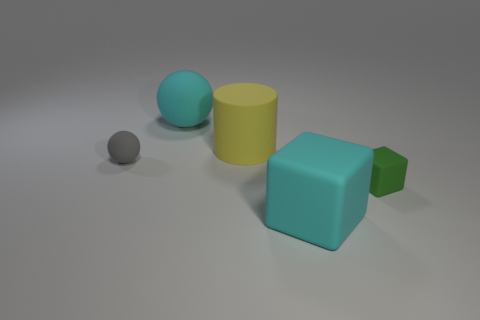Add 3 small green cubes. How many objects exist? 8 Subtract all brown cylinders. How many brown cubes are left? 0 Subtract all large green matte objects. Subtract all big cyan matte things. How many objects are left? 3 Add 2 small green objects. How many small green objects are left? 3 Add 3 large gray cylinders. How many large gray cylinders exist? 3 Subtract 0 blue balls. How many objects are left? 5 Subtract all cylinders. How many objects are left? 4 Subtract 2 blocks. How many blocks are left? 0 Subtract all gray spheres. Subtract all cyan blocks. How many spheres are left? 1 